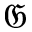<formula> <loc_0><loc_0><loc_500><loc_500>\mathfrak { G }</formula> 